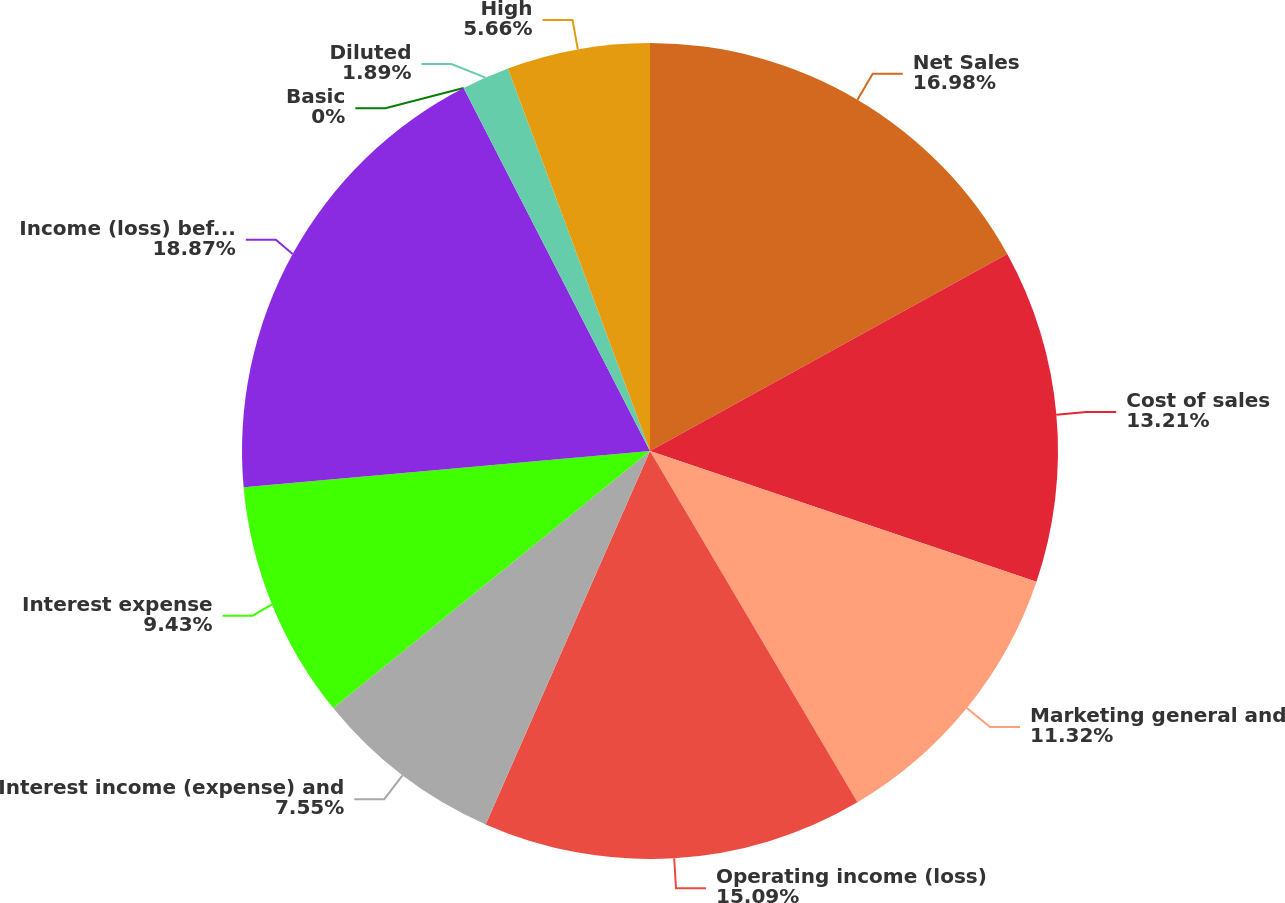Convert chart to OTSL. <chart><loc_0><loc_0><loc_500><loc_500><pie_chart><fcel>Net Sales<fcel>Cost of sales<fcel>Marketing general and<fcel>Operating income (loss)<fcel>Interest income (expense) and<fcel>Interest expense<fcel>Income (loss) before equity in<fcel>Basic<fcel>Diluted<fcel>High<nl><fcel>16.98%<fcel>13.21%<fcel>11.32%<fcel>15.09%<fcel>7.55%<fcel>9.43%<fcel>18.87%<fcel>0.0%<fcel>1.89%<fcel>5.66%<nl></chart> 